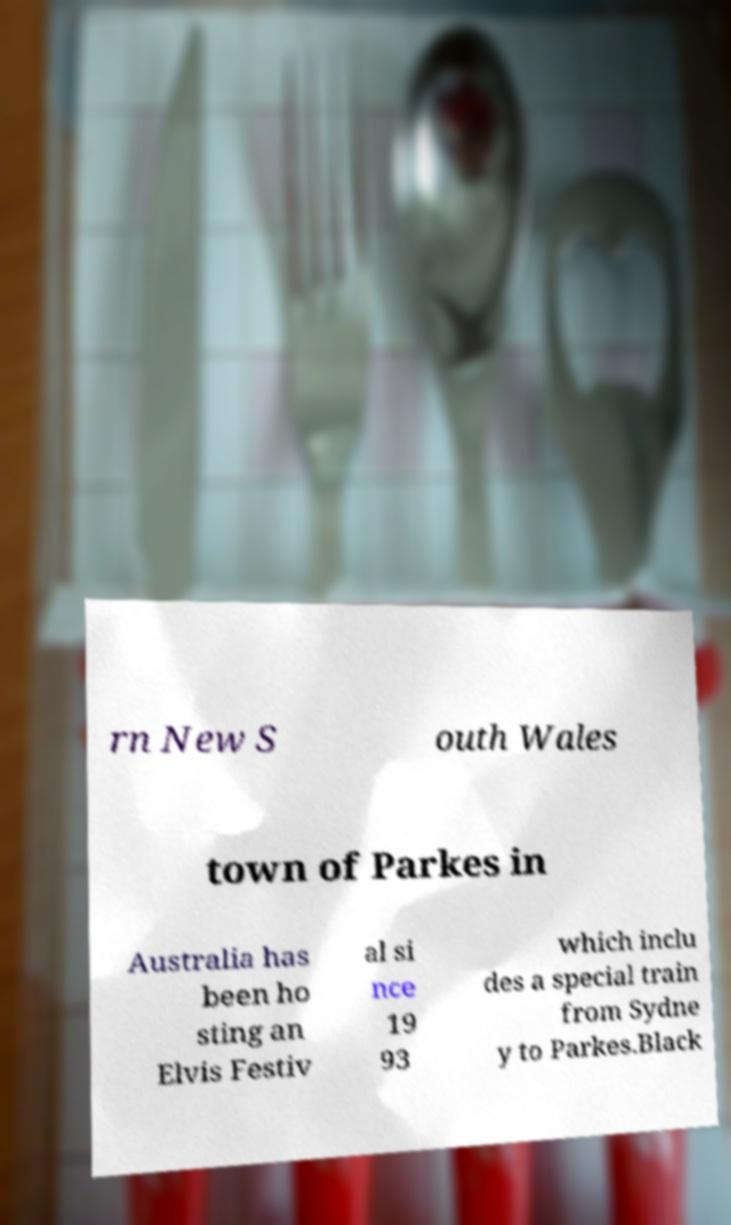For documentation purposes, I need the text within this image transcribed. Could you provide that? rn New S outh Wales town of Parkes in Australia has been ho sting an Elvis Festiv al si nce 19 93 which inclu des a special train from Sydne y to Parkes.Black 